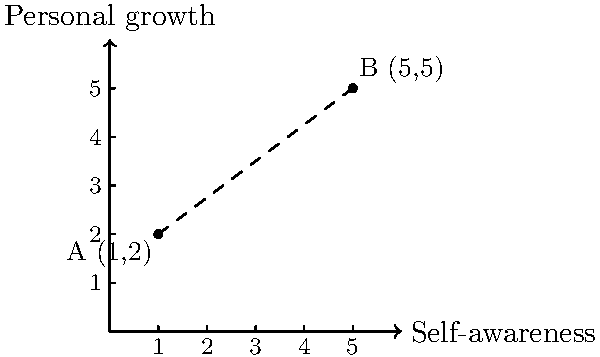On a graph representing personal growth, point A (1,2) symbolizes a client's initial state of self-awareness and personal development. After a period of therapy and self-reflection, the client reaches point B (5,5). Calculate the distance between points A and B, representing the client's journey of self-improvement. Round your answer to two decimal places. To calculate the distance between two points on a coordinate plane, we can use the distance formula:

$$d = \sqrt{(x_2 - x_1)^2 + (y_2 - y_1)^2}$$

Where $(x_1, y_1)$ are the coordinates of the first point and $(x_2, y_2)$ are the coordinates of the second point.

Given:
Point A: $(1, 2)$
Point B: $(5, 5)$

Let's plug these values into the formula:

$$\begin{align*}
d &= \sqrt{(5 - 1)^2 + (5 - 2)^2} \\
&= \sqrt{4^2 + 3^2} \\
&= \sqrt{16 + 9} \\
&= \sqrt{25} \\
&= 5
\end{align*}$$

The exact distance is 5 units. Since the question asks for the answer rounded to two decimal places, our final answer is 5.00.

This distance represents the magnitude of the client's personal growth and increased self-awareness achieved through therapy and self-reflection.
Answer: 5.00 